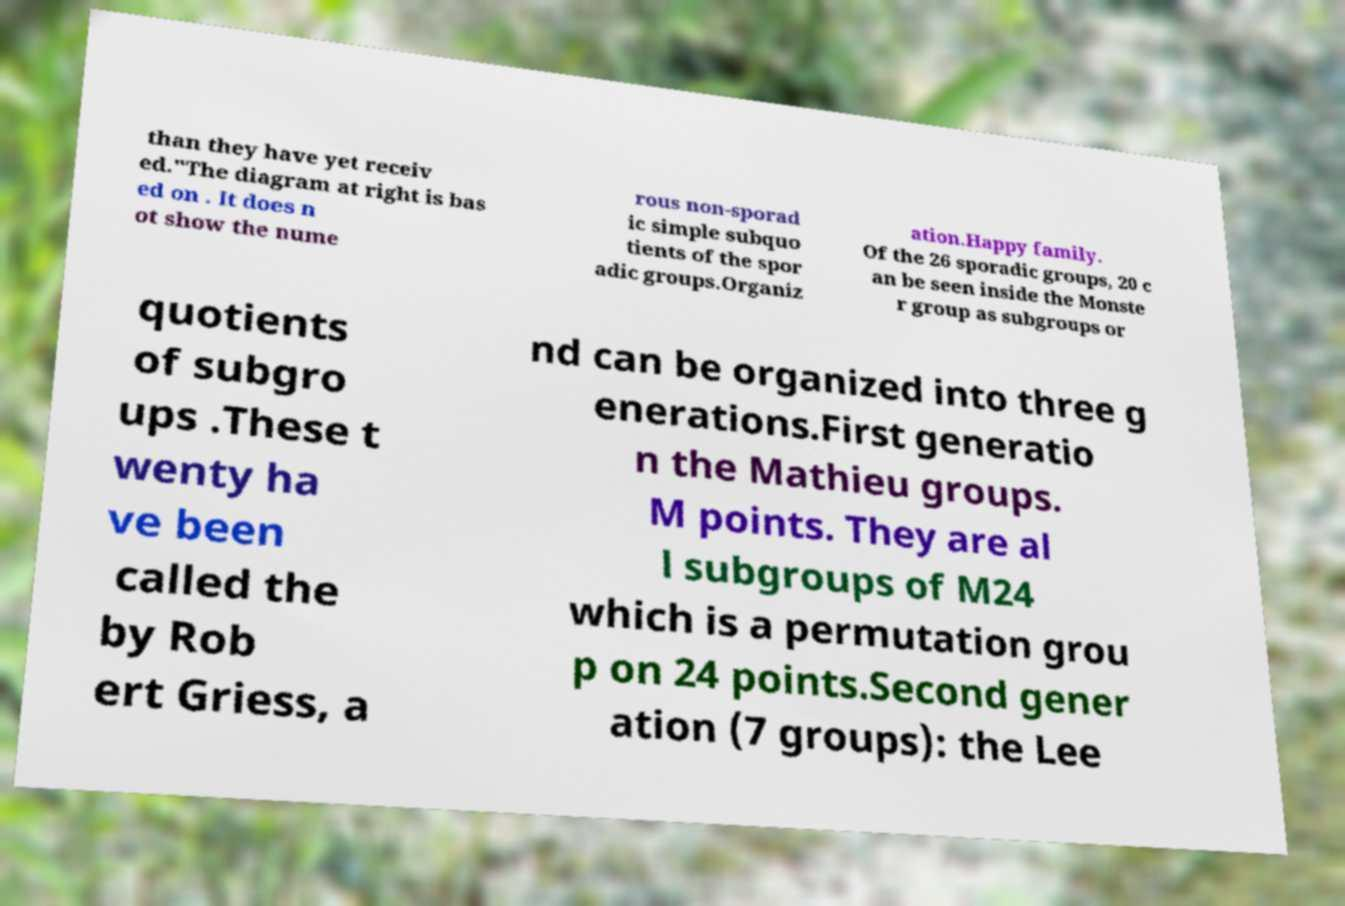For documentation purposes, I need the text within this image transcribed. Could you provide that? than they have yet receiv ed."The diagram at right is bas ed on . It does n ot show the nume rous non-sporad ic simple subquo tients of the spor adic groups.Organiz ation.Happy family. Of the 26 sporadic groups, 20 c an be seen inside the Monste r group as subgroups or quotients of subgro ups .These t wenty ha ve been called the by Rob ert Griess, a nd can be organized into three g enerations.First generatio n the Mathieu groups. M points. They are al l subgroups of M24 which is a permutation grou p on 24 points.Second gener ation (7 groups): the Lee 